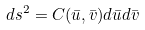<formula> <loc_0><loc_0><loc_500><loc_500>d s ^ { 2 } = C ( \bar { u } , \bar { v } ) d \bar { u } d \bar { v }</formula> 